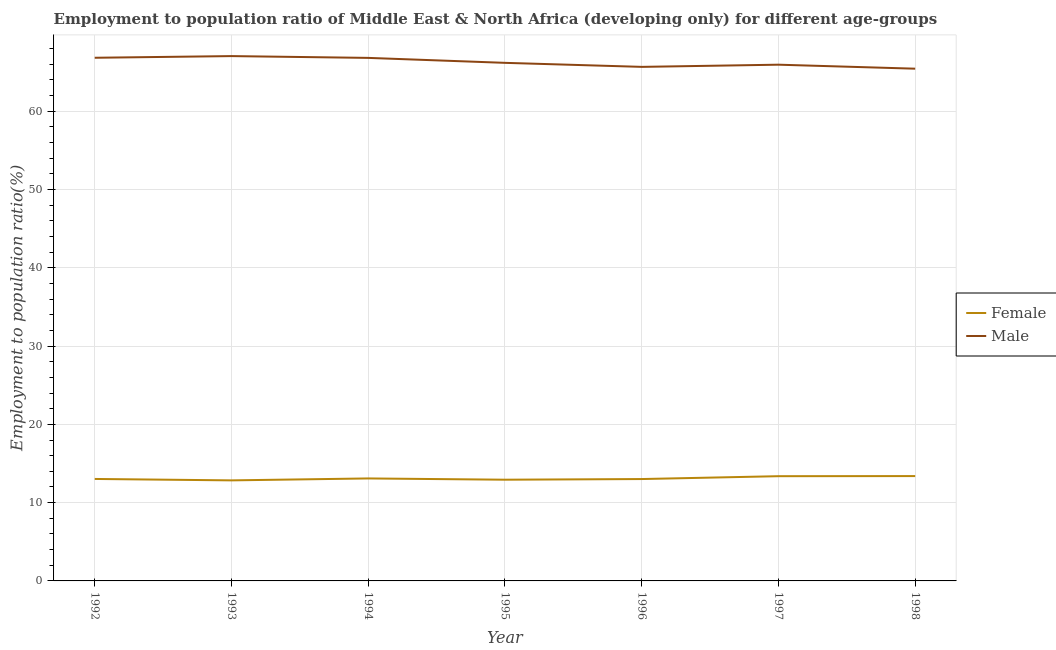What is the employment to population ratio(female) in 1993?
Keep it short and to the point. 12.84. Across all years, what is the maximum employment to population ratio(male)?
Provide a short and direct response. 67.05. Across all years, what is the minimum employment to population ratio(female)?
Provide a short and direct response. 12.84. In which year was the employment to population ratio(female) maximum?
Give a very brief answer. 1998. What is the total employment to population ratio(female) in the graph?
Ensure brevity in your answer.  91.68. What is the difference between the employment to population ratio(male) in 1994 and that in 1996?
Keep it short and to the point. 1.15. What is the difference between the employment to population ratio(female) in 1998 and the employment to population ratio(male) in 1993?
Your answer should be compact. -53.65. What is the average employment to population ratio(male) per year?
Offer a terse response. 66.28. In the year 1998, what is the difference between the employment to population ratio(female) and employment to population ratio(male)?
Offer a terse response. -52.04. What is the ratio of the employment to population ratio(male) in 1993 to that in 1996?
Keep it short and to the point. 1.02. What is the difference between the highest and the second highest employment to population ratio(male)?
Your answer should be compact. 0.21. What is the difference between the highest and the lowest employment to population ratio(male)?
Give a very brief answer. 1.61. In how many years, is the employment to population ratio(female) greater than the average employment to population ratio(female) taken over all years?
Ensure brevity in your answer.  2. Is the sum of the employment to population ratio(male) in 1992 and 1997 greater than the maximum employment to population ratio(female) across all years?
Provide a succinct answer. Yes. Is the employment to population ratio(male) strictly greater than the employment to population ratio(female) over the years?
Give a very brief answer. Yes. Is the employment to population ratio(female) strictly less than the employment to population ratio(male) over the years?
Your answer should be very brief. Yes. How many lines are there?
Your response must be concise. 2. Does the graph contain grids?
Give a very brief answer. Yes. Where does the legend appear in the graph?
Your answer should be very brief. Center right. What is the title of the graph?
Give a very brief answer. Employment to population ratio of Middle East & North Africa (developing only) for different age-groups. Does "Underweight" appear as one of the legend labels in the graph?
Your answer should be compact. No. What is the label or title of the Y-axis?
Give a very brief answer. Employment to population ratio(%). What is the Employment to population ratio(%) in Female in 1992?
Provide a succinct answer. 13.03. What is the Employment to population ratio(%) in Male in 1992?
Your answer should be compact. 66.83. What is the Employment to population ratio(%) in Female in 1993?
Provide a short and direct response. 12.84. What is the Employment to population ratio(%) in Male in 1993?
Give a very brief answer. 67.05. What is the Employment to population ratio(%) in Female in 1994?
Provide a succinct answer. 13.09. What is the Employment to population ratio(%) of Male in 1994?
Your response must be concise. 66.82. What is the Employment to population ratio(%) of Female in 1995?
Ensure brevity in your answer.  12.93. What is the Employment to population ratio(%) of Male in 1995?
Your answer should be very brief. 66.18. What is the Employment to population ratio(%) of Female in 1996?
Make the answer very short. 13.01. What is the Employment to population ratio(%) in Male in 1996?
Ensure brevity in your answer.  65.67. What is the Employment to population ratio(%) of Female in 1997?
Your answer should be very brief. 13.38. What is the Employment to population ratio(%) of Male in 1997?
Offer a terse response. 65.95. What is the Employment to population ratio(%) of Female in 1998?
Keep it short and to the point. 13.39. What is the Employment to population ratio(%) of Male in 1998?
Provide a short and direct response. 65.44. Across all years, what is the maximum Employment to population ratio(%) in Female?
Offer a very short reply. 13.39. Across all years, what is the maximum Employment to population ratio(%) in Male?
Your response must be concise. 67.05. Across all years, what is the minimum Employment to population ratio(%) in Female?
Give a very brief answer. 12.84. Across all years, what is the minimum Employment to population ratio(%) of Male?
Ensure brevity in your answer.  65.44. What is the total Employment to population ratio(%) in Female in the graph?
Give a very brief answer. 91.68. What is the total Employment to population ratio(%) in Male in the graph?
Offer a very short reply. 463.94. What is the difference between the Employment to population ratio(%) in Female in 1992 and that in 1993?
Your answer should be compact. 0.18. What is the difference between the Employment to population ratio(%) in Male in 1992 and that in 1993?
Your answer should be compact. -0.21. What is the difference between the Employment to population ratio(%) in Female in 1992 and that in 1994?
Offer a terse response. -0.07. What is the difference between the Employment to population ratio(%) of Male in 1992 and that in 1994?
Make the answer very short. 0.01. What is the difference between the Employment to population ratio(%) in Female in 1992 and that in 1995?
Your answer should be compact. 0.1. What is the difference between the Employment to population ratio(%) of Male in 1992 and that in 1995?
Your response must be concise. 0.65. What is the difference between the Employment to population ratio(%) of Female in 1992 and that in 1996?
Your answer should be compact. 0.01. What is the difference between the Employment to population ratio(%) in Male in 1992 and that in 1996?
Keep it short and to the point. 1.16. What is the difference between the Employment to population ratio(%) of Female in 1992 and that in 1997?
Your answer should be compact. -0.35. What is the difference between the Employment to population ratio(%) in Male in 1992 and that in 1997?
Provide a short and direct response. 0.88. What is the difference between the Employment to population ratio(%) in Female in 1992 and that in 1998?
Give a very brief answer. -0.37. What is the difference between the Employment to population ratio(%) of Male in 1992 and that in 1998?
Your answer should be very brief. 1.4. What is the difference between the Employment to population ratio(%) in Female in 1993 and that in 1994?
Offer a terse response. -0.25. What is the difference between the Employment to population ratio(%) of Male in 1993 and that in 1994?
Your answer should be very brief. 0.23. What is the difference between the Employment to population ratio(%) of Female in 1993 and that in 1995?
Offer a very short reply. -0.09. What is the difference between the Employment to population ratio(%) in Male in 1993 and that in 1995?
Offer a terse response. 0.86. What is the difference between the Employment to population ratio(%) in Female in 1993 and that in 1996?
Offer a very short reply. -0.17. What is the difference between the Employment to population ratio(%) of Male in 1993 and that in 1996?
Ensure brevity in your answer.  1.38. What is the difference between the Employment to population ratio(%) of Female in 1993 and that in 1997?
Make the answer very short. -0.54. What is the difference between the Employment to population ratio(%) of Male in 1993 and that in 1997?
Offer a terse response. 1.1. What is the difference between the Employment to population ratio(%) in Female in 1993 and that in 1998?
Provide a short and direct response. -0.55. What is the difference between the Employment to population ratio(%) of Male in 1993 and that in 1998?
Your answer should be compact. 1.61. What is the difference between the Employment to population ratio(%) of Female in 1994 and that in 1995?
Make the answer very short. 0.16. What is the difference between the Employment to population ratio(%) in Male in 1994 and that in 1995?
Provide a short and direct response. 0.63. What is the difference between the Employment to population ratio(%) of Female in 1994 and that in 1996?
Offer a terse response. 0.08. What is the difference between the Employment to population ratio(%) in Male in 1994 and that in 1996?
Give a very brief answer. 1.15. What is the difference between the Employment to population ratio(%) in Female in 1994 and that in 1997?
Provide a succinct answer. -0.29. What is the difference between the Employment to population ratio(%) of Male in 1994 and that in 1997?
Keep it short and to the point. 0.87. What is the difference between the Employment to population ratio(%) in Female in 1994 and that in 1998?
Your response must be concise. -0.3. What is the difference between the Employment to population ratio(%) of Male in 1994 and that in 1998?
Make the answer very short. 1.38. What is the difference between the Employment to population ratio(%) in Female in 1995 and that in 1996?
Make the answer very short. -0.08. What is the difference between the Employment to population ratio(%) of Male in 1995 and that in 1996?
Make the answer very short. 0.51. What is the difference between the Employment to population ratio(%) of Female in 1995 and that in 1997?
Your answer should be very brief. -0.45. What is the difference between the Employment to population ratio(%) of Male in 1995 and that in 1997?
Provide a succinct answer. 0.24. What is the difference between the Employment to population ratio(%) in Female in 1995 and that in 1998?
Your answer should be very brief. -0.46. What is the difference between the Employment to population ratio(%) in Male in 1995 and that in 1998?
Your response must be concise. 0.75. What is the difference between the Employment to population ratio(%) in Female in 1996 and that in 1997?
Your answer should be compact. -0.37. What is the difference between the Employment to population ratio(%) in Male in 1996 and that in 1997?
Keep it short and to the point. -0.28. What is the difference between the Employment to population ratio(%) in Female in 1996 and that in 1998?
Make the answer very short. -0.38. What is the difference between the Employment to population ratio(%) of Male in 1996 and that in 1998?
Provide a succinct answer. 0.23. What is the difference between the Employment to population ratio(%) of Female in 1997 and that in 1998?
Provide a succinct answer. -0.01. What is the difference between the Employment to population ratio(%) of Male in 1997 and that in 1998?
Provide a succinct answer. 0.51. What is the difference between the Employment to population ratio(%) of Female in 1992 and the Employment to population ratio(%) of Male in 1993?
Your response must be concise. -54.02. What is the difference between the Employment to population ratio(%) in Female in 1992 and the Employment to population ratio(%) in Male in 1994?
Your answer should be compact. -53.79. What is the difference between the Employment to population ratio(%) in Female in 1992 and the Employment to population ratio(%) in Male in 1995?
Offer a very short reply. -53.16. What is the difference between the Employment to population ratio(%) of Female in 1992 and the Employment to population ratio(%) of Male in 1996?
Give a very brief answer. -52.65. What is the difference between the Employment to population ratio(%) in Female in 1992 and the Employment to population ratio(%) in Male in 1997?
Your answer should be very brief. -52.92. What is the difference between the Employment to population ratio(%) in Female in 1992 and the Employment to population ratio(%) in Male in 1998?
Offer a terse response. -52.41. What is the difference between the Employment to population ratio(%) in Female in 1993 and the Employment to population ratio(%) in Male in 1994?
Keep it short and to the point. -53.97. What is the difference between the Employment to population ratio(%) in Female in 1993 and the Employment to population ratio(%) in Male in 1995?
Your answer should be very brief. -53.34. What is the difference between the Employment to population ratio(%) in Female in 1993 and the Employment to population ratio(%) in Male in 1996?
Offer a terse response. -52.83. What is the difference between the Employment to population ratio(%) of Female in 1993 and the Employment to population ratio(%) of Male in 1997?
Give a very brief answer. -53.1. What is the difference between the Employment to population ratio(%) of Female in 1993 and the Employment to population ratio(%) of Male in 1998?
Provide a short and direct response. -52.59. What is the difference between the Employment to population ratio(%) in Female in 1994 and the Employment to population ratio(%) in Male in 1995?
Make the answer very short. -53.09. What is the difference between the Employment to population ratio(%) in Female in 1994 and the Employment to population ratio(%) in Male in 1996?
Provide a short and direct response. -52.58. What is the difference between the Employment to population ratio(%) in Female in 1994 and the Employment to population ratio(%) in Male in 1997?
Make the answer very short. -52.86. What is the difference between the Employment to population ratio(%) in Female in 1994 and the Employment to population ratio(%) in Male in 1998?
Ensure brevity in your answer.  -52.34. What is the difference between the Employment to population ratio(%) in Female in 1995 and the Employment to population ratio(%) in Male in 1996?
Keep it short and to the point. -52.74. What is the difference between the Employment to population ratio(%) of Female in 1995 and the Employment to population ratio(%) of Male in 1997?
Give a very brief answer. -53.02. What is the difference between the Employment to population ratio(%) in Female in 1995 and the Employment to population ratio(%) in Male in 1998?
Your answer should be compact. -52.51. What is the difference between the Employment to population ratio(%) in Female in 1996 and the Employment to population ratio(%) in Male in 1997?
Your answer should be compact. -52.94. What is the difference between the Employment to population ratio(%) in Female in 1996 and the Employment to population ratio(%) in Male in 1998?
Offer a terse response. -52.42. What is the difference between the Employment to population ratio(%) of Female in 1997 and the Employment to population ratio(%) of Male in 1998?
Provide a short and direct response. -52.06. What is the average Employment to population ratio(%) of Female per year?
Make the answer very short. 13.1. What is the average Employment to population ratio(%) in Male per year?
Keep it short and to the point. 66.28. In the year 1992, what is the difference between the Employment to population ratio(%) of Female and Employment to population ratio(%) of Male?
Provide a succinct answer. -53.81. In the year 1993, what is the difference between the Employment to population ratio(%) of Female and Employment to population ratio(%) of Male?
Provide a succinct answer. -54.2. In the year 1994, what is the difference between the Employment to population ratio(%) in Female and Employment to population ratio(%) in Male?
Give a very brief answer. -53.73. In the year 1995, what is the difference between the Employment to population ratio(%) in Female and Employment to population ratio(%) in Male?
Offer a very short reply. -53.25. In the year 1996, what is the difference between the Employment to population ratio(%) of Female and Employment to population ratio(%) of Male?
Offer a terse response. -52.66. In the year 1997, what is the difference between the Employment to population ratio(%) of Female and Employment to population ratio(%) of Male?
Keep it short and to the point. -52.57. In the year 1998, what is the difference between the Employment to population ratio(%) of Female and Employment to population ratio(%) of Male?
Give a very brief answer. -52.04. What is the ratio of the Employment to population ratio(%) of Female in 1992 to that in 1993?
Your answer should be compact. 1.01. What is the ratio of the Employment to population ratio(%) of Male in 1992 to that in 1993?
Offer a very short reply. 1. What is the ratio of the Employment to population ratio(%) in Female in 1992 to that in 1995?
Offer a very short reply. 1.01. What is the ratio of the Employment to population ratio(%) in Male in 1992 to that in 1995?
Keep it short and to the point. 1.01. What is the ratio of the Employment to population ratio(%) of Female in 1992 to that in 1996?
Keep it short and to the point. 1. What is the ratio of the Employment to population ratio(%) of Male in 1992 to that in 1996?
Offer a terse response. 1.02. What is the ratio of the Employment to population ratio(%) of Female in 1992 to that in 1997?
Ensure brevity in your answer.  0.97. What is the ratio of the Employment to population ratio(%) of Male in 1992 to that in 1997?
Provide a short and direct response. 1.01. What is the ratio of the Employment to population ratio(%) in Female in 1992 to that in 1998?
Keep it short and to the point. 0.97. What is the ratio of the Employment to population ratio(%) in Male in 1992 to that in 1998?
Keep it short and to the point. 1.02. What is the ratio of the Employment to population ratio(%) of Female in 1993 to that in 1994?
Offer a terse response. 0.98. What is the ratio of the Employment to population ratio(%) in Female in 1993 to that in 1996?
Offer a very short reply. 0.99. What is the ratio of the Employment to population ratio(%) in Male in 1993 to that in 1996?
Keep it short and to the point. 1.02. What is the ratio of the Employment to population ratio(%) in Male in 1993 to that in 1997?
Give a very brief answer. 1.02. What is the ratio of the Employment to population ratio(%) of Female in 1993 to that in 1998?
Your answer should be compact. 0.96. What is the ratio of the Employment to population ratio(%) in Male in 1993 to that in 1998?
Your answer should be very brief. 1.02. What is the ratio of the Employment to population ratio(%) in Female in 1994 to that in 1995?
Your answer should be compact. 1.01. What is the ratio of the Employment to population ratio(%) of Male in 1994 to that in 1995?
Provide a short and direct response. 1.01. What is the ratio of the Employment to population ratio(%) in Male in 1994 to that in 1996?
Provide a short and direct response. 1.02. What is the ratio of the Employment to population ratio(%) of Female in 1994 to that in 1997?
Provide a short and direct response. 0.98. What is the ratio of the Employment to population ratio(%) in Male in 1994 to that in 1997?
Give a very brief answer. 1.01. What is the ratio of the Employment to population ratio(%) in Female in 1994 to that in 1998?
Ensure brevity in your answer.  0.98. What is the ratio of the Employment to population ratio(%) of Male in 1994 to that in 1998?
Your response must be concise. 1.02. What is the ratio of the Employment to population ratio(%) in Male in 1995 to that in 1996?
Make the answer very short. 1.01. What is the ratio of the Employment to population ratio(%) of Female in 1995 to that in 1997?
Ensure brevity in your answer.  0.97. What is the ratio of the Employment to population ratio(%) in Female in 1995 to that in 1998?
Your response must be concise. 0.97. What is the ratio of the Employment to population ratio(%) of Male in 1995 to that in 1998?
Offer a terse response. 1.01. What is the ratio of the Employment to population ratio(%) of Female in 1996 to that in 1997?
Provide a succinct answer. 0.97. What is the ratio of the Employment to population ratio(%) of Female in 1996 to that in 1998?
Give a very brief answer. 0.97. What is the ratio of the Employment to population ratio(%) of Female in 1997 to that in 1998?
Ensure brevity in your answer.  1. What is the ratio of the Employment to population ratio(%) of Male in 1997 to that in 1998?
Ensure brevity in your answer.  1.01. What is the difference between the highest and the second highest Employment to population ratio(%) in Female?
Give a very brief answer. 0.01. What is the difference between the highest and the second highest Employment to population ratio(%) of Male?
Ensure brevity in your answer.  0.21. What is the difference between the highest and the lowest Employment to population ratio(%) of Female?
Your response must be concise. 0.55. What is the difference between the highest and the lowest Employment to population ratio(%) in Male?
Your answer should be very brief. 1.61. 